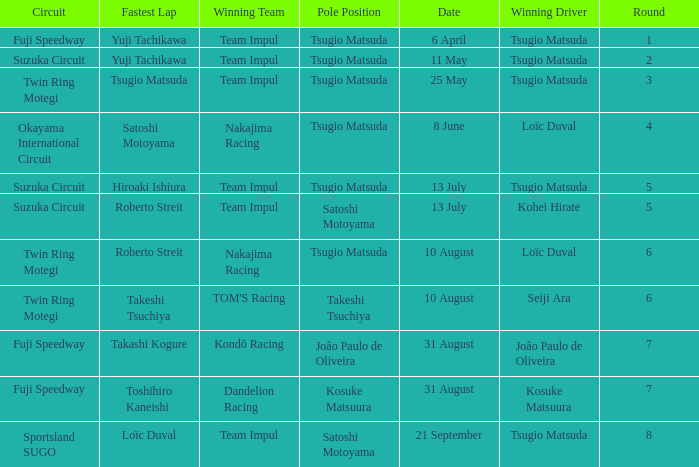What is the fastest lap for Seiji Ara? Takeshi Tsuchiya. 